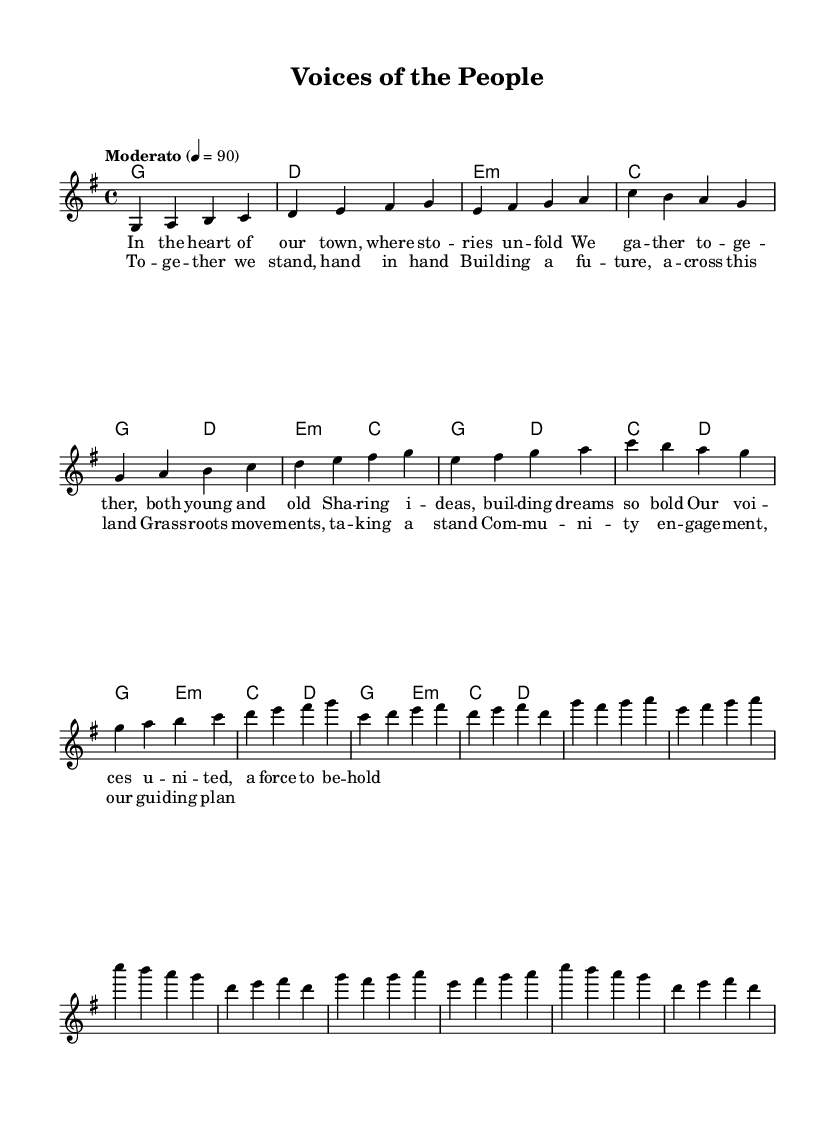What is the key signature of this music? The key signature written at the beginning of the score indicates that the piece is in G major, which has one sharp (F#).
Answer: G major What is the time signature of this music? The time signature at the beginning shows that the music is written in 4/4 time, which means there are four beats per measure and the quarter note gets one beat.
Answer: 4/4 What is the tempo marking of the piece? The tempo is indicated as "Moderato" with a metronome marking of 4 = 90, suggesting a moderate pace.
Answer: Moderato How many measures are in the Chorus section? Counting the measures written under the 'Chorus' section, there are a total of 8 measures.
Answer: 8 What is the first lyric of the verse? The verse begins with "In the heart of our town," indicating the opening line of the lyrics.
Answer: In the heart of our town What harmony is used during the Chorus? The harmony indicated in the chorus section shows that it alternates between G major, E minor, C major, and D major chords across the measures.
Answer: G, E minor, C, D What theme does the song express? The lyrics and title express themes of community engagement and grassroots movements, highlighting unity and collective effort.
Answer: Community engagement and grassroots movements 